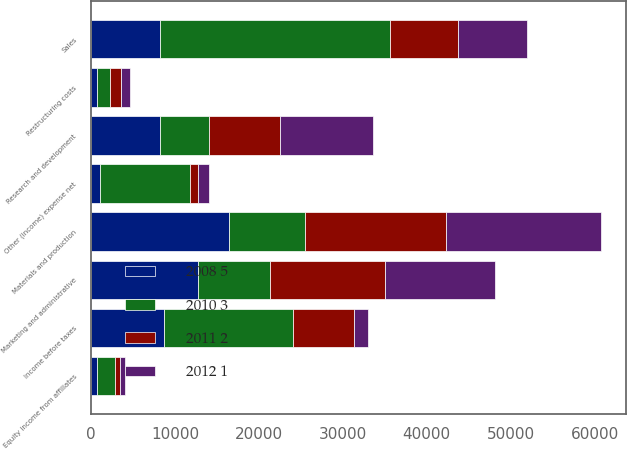Convert chart to OTSL. <chart><loc_0><loc_0><loc_500><loc_500><stacked_bar_chart><ecel><fcel>Sales<fcel>Materials and production<fcel>Marketing and administrative<fcel>Research and development<fcel>Restructuring costs<fcel>Equity income from affiliates<fcel>Other (income) expense net<fcel>Income before taxes<nl><fcel>2008 5<fcel>8168<fcel>16446<fcel>12776<fcel>8168<fcel>664<fcel>642<fcel>1116<fcel>8739<nl><fcel>2011 2<fcel>8168<fcel>16871<fcel>13733<fcel>8467<fcel>1306<fcel>610<fcel>946<fcel>7334<nl><fcel>2012 1<fcel>8168<fcel>18396<fcel>13125<fcel>11111<fcel>985<fcel>587<fcel>1304<fcel>1653<nl><fcel>2010 3<fcel>27428<fcel>9019<fcel>8543<fcel>5845<fcel>1634<fcel>2235<fcel>10668<fcel>15290<nl></chart> 